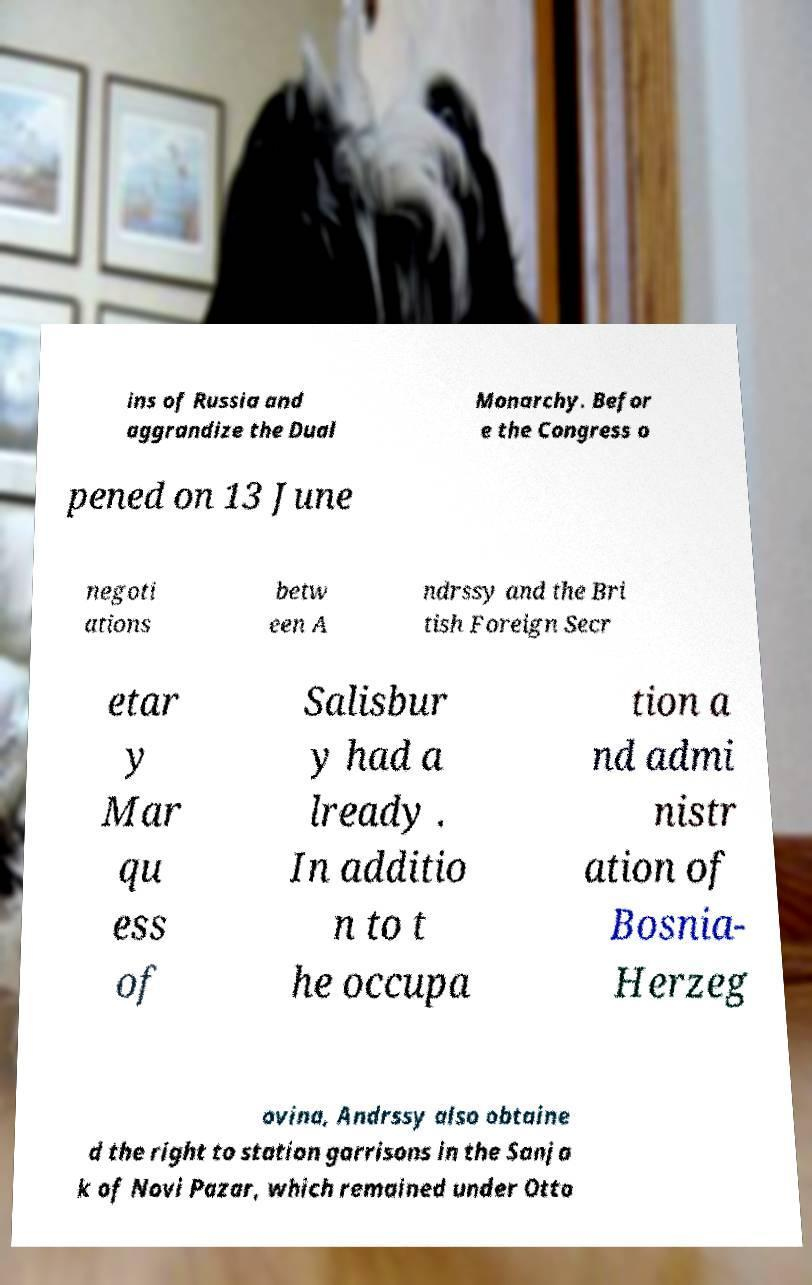I need the written content from this picture converted into text. Can you do that? ins of Russia and aggrandize the Dual Monarchy. Befor e the Congress o pened on 13 June negoti ations betw een A ndrssy and the Bri tish Foreign Secr etar y Mar qu ess of Salisbur y had a lready . In additio n to t he occupa tion a nd admi nistr ation of Bosnia- Herzeg ovina, Andrssy also obtaine d the right to station garrisons in the Sanja k of Novi Pazar, which remained under Otto 